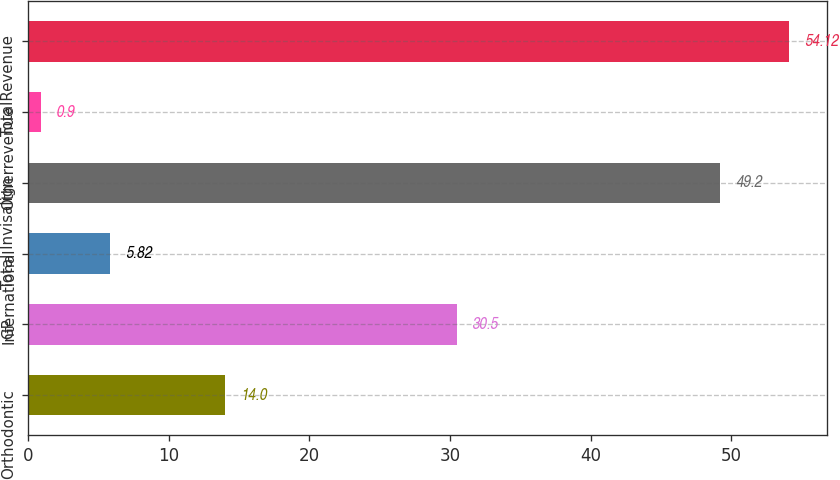Convert chart. <chart><loc_0><loc_0><loc_500><loc_500><bar_chart><fcel>Orthodontic<fcel>GP<fcel>International<fcel>Total Invisalign<fcel>Otherrevenue<fcel>TotalRevenue<nl><fcel>14<fcel>30.5<fcel>5.82<fcel>49.2<fcel>0.9<fcel>54.12<nl></chart> 